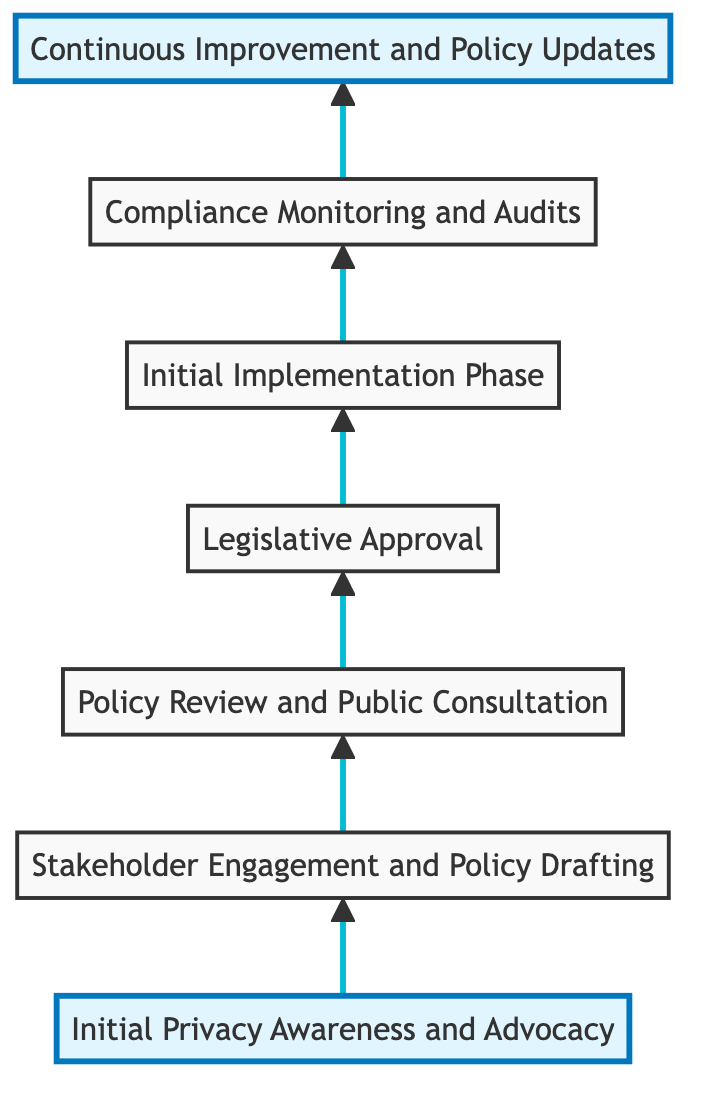What is the first step in the flow chart? The first step in the flow chart is 'Initial Privacy Awareness and Advocacy', as it is positioned at the bottom of the diagram while flowing upwards.
Answer: Initial Privacy Awareness and Advocacy How many total steps are in the diagram? There are seven steps in total, which are represented by the nodes in the flow chart from bottom to top.
Answer: 7 Which step follows 'Legislative Approval'? According to the flow direction in the diagram, the step that follows 'Legislative Approval' is 'Initial Implementation Phase'.
Answer: Initial Implementation Phase What is the last step in the diagram? The last step in the diagram is 'Continuous Improvement and Policy Updates', as it is positioned at the topmost point of the flow chart.
Answer: Continuous Improvement and Policy Updates Which two steps are directly connected before 'Compliance Monitoring and Audits'? The two steps directly connected before 'Compliance Monitoring and Audits' are 'Initial Implementation Phase' and 'Legislative Approval', with the flow leading up to audits after implementation.
Answer: Initial Implementation Phase and Legislative Approval What type of policies do the public institutions implement during the 'Initial Implementation Phase'? During the 'Initial Implementation Phase', the public institutions implement approved privacy policies, as indicated in the description of that step.
Answer: Approved privacy policies How many reviews and consultations occur before the legislation is approved? One review and public consultation occur prior to legislative approval, which is indicated in the flow between 'Policy Review and Public Consultation' and 'Legislative Approval'.
Answer: One Which steps involve stakeholder collaboration? The steps that involve stakeholder collaboration are 'Stakeholder Engagement and Policy Drafting' and 'Policy Review and Public Consultation', as both require input from various stakeholders.
Answer: Stakeholder Engagement and Policy Drafting, Policy Review and Public Consultation 